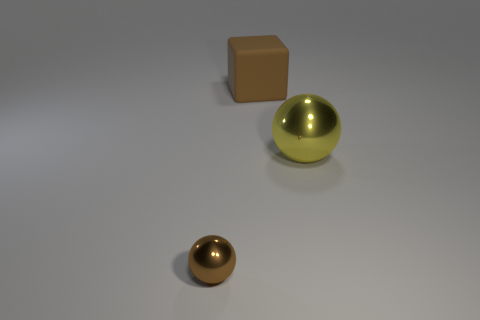What material do the objects in the image seem to be made of? The objects appear to be made of different materials. The large sphere and the smaller object have a reflective surface, suggesting they could be metallic, while the cube looks like it's made of rubber due to its matte, non-reflective texture. 